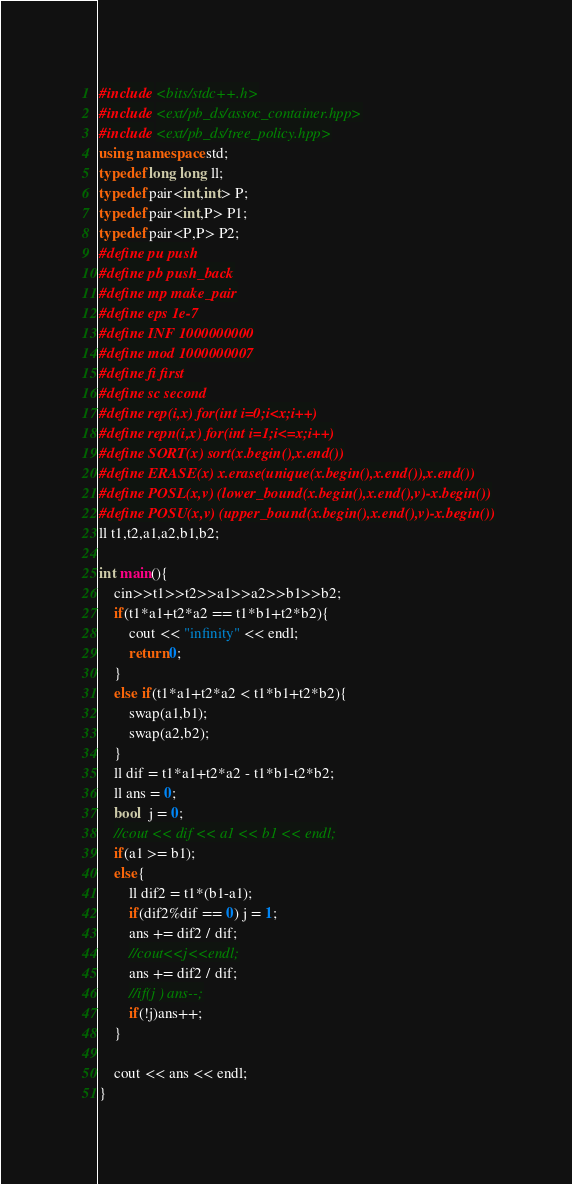Convert code to text. <code><loc_0><loc_0><loc_500><loc_500><_C++_>#include <bits/stdc++.h>
#include <ext/pb_ds/assoc_container.hpp>
#include <ext/pb_ds/tree_policy.hpp>
using namespace std;
typedef long long ll;
typedef pair<int,int> P;
typedef pair<int,P> P1;
typedef pair<P,P> P2;
#define pu push
#define pb push_back
#define mp make_pair
#define eps 1e-7
#define INF 1000000000
#define mod 1000000007
#define fi first
#define sc second
#define rep(i,x) for(int i=0;i<x;i++)
#define repn(i,x) for(int i=1;i<=x;i++)
#define SORT(x) sort(x.begin(),x.end())
#define ERASE(x) x.erase(unique(x.begin(),x.end()),x.end())
#define POSL(x,v) (lower_bound(x.begin(),x.end(),v)-x.begin())
#define POSU(x,v) (upper_bound(x.begin(),x.end(),v)-x.begin())
ll t1,t2,a1,a2,b1,b2;

int main(){
	cin>>t1>>t2>>a1>>a2>>b1>>b2;
	if(t1*a1+t2*a2 == t1*b1+t2*b2){
		cout << "infinity" << endl;
		return 0;
	}
	else if(t1*a1+t2*a2 < t1*b1+t2*b2){
		swap(a1,b1);
		swap(a2,b2);
	}
	ll dif = t1*a1+t2*a2 - t1*b1-t2*b2;
	ll ans = 0;
	bool  j = 0;
	//cout << dif << a1 << b1 << endl;
	if(a1 >= b1);
	else{
		ll dif2 = t1*(b1-a1);
		if(dif2%dif == 0) j = 1;
		ans += dif2 / dif;
		//cout<<j<<endl;
		ans += dif2 / dif;
		//if(j ) ans--;
		if(!j)ans++;
	}
	
	cout << ans << endl;
}</code> 